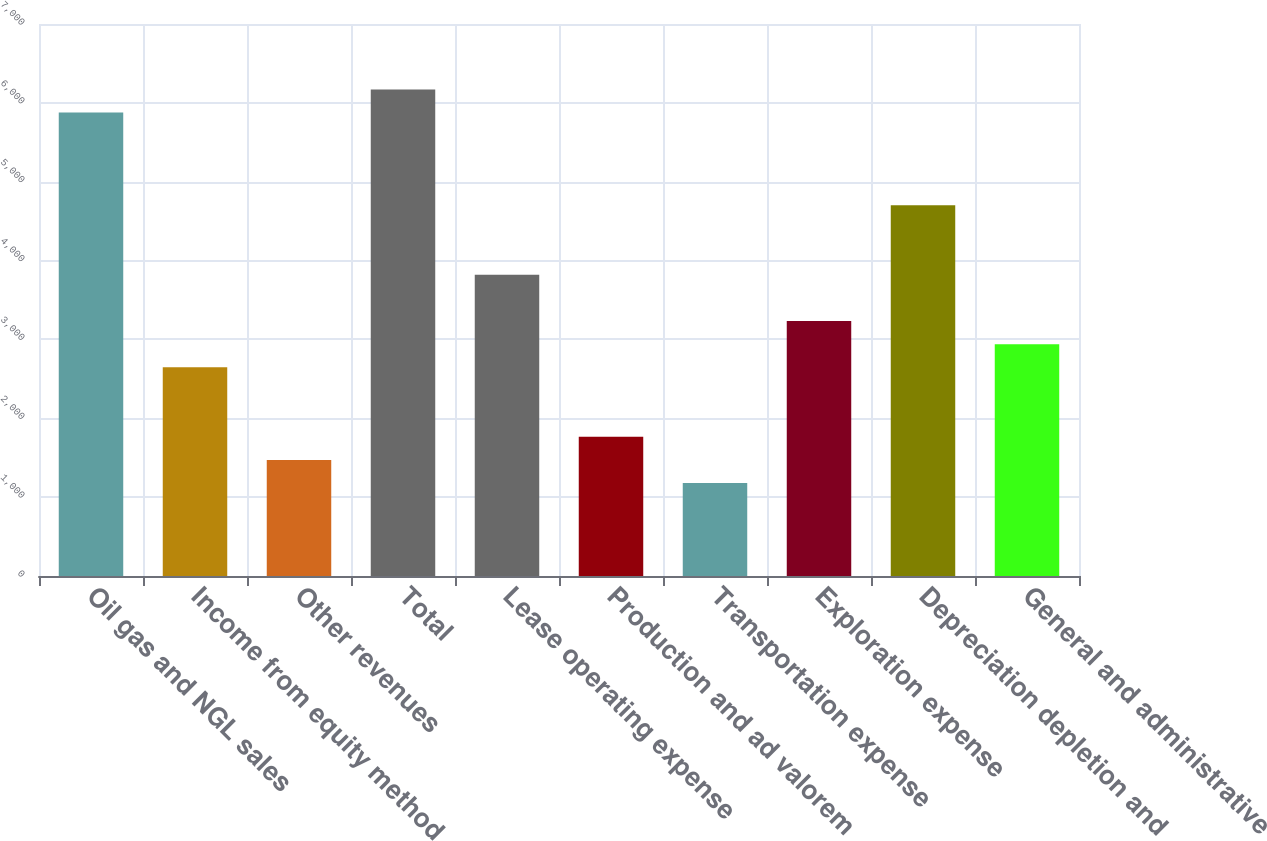Convert chart to OTSL. <chart><loc_0><loc_0><loc_500><loc_500><bar_chart><fcel>Oil gas and NGL sales<fcel>Income from equity method<fcel>Other revenues<fcel>Total<fcel>Lease operating expense<fcel>Production and ad valorem<fcel>Transportation expense<fcel>Exploration expense<fcel>Depreciation depletion and<fcel>General and administrative<nl><fcel>5876.19<fcel>2646.37<fcel>1471.89<fcel>6169.81<fcel>3820.85<fcel>1765.51<fcel>1178.27<fcel>3233.61<fcel>4701.71<fcel>2939.99<nl></chart> 